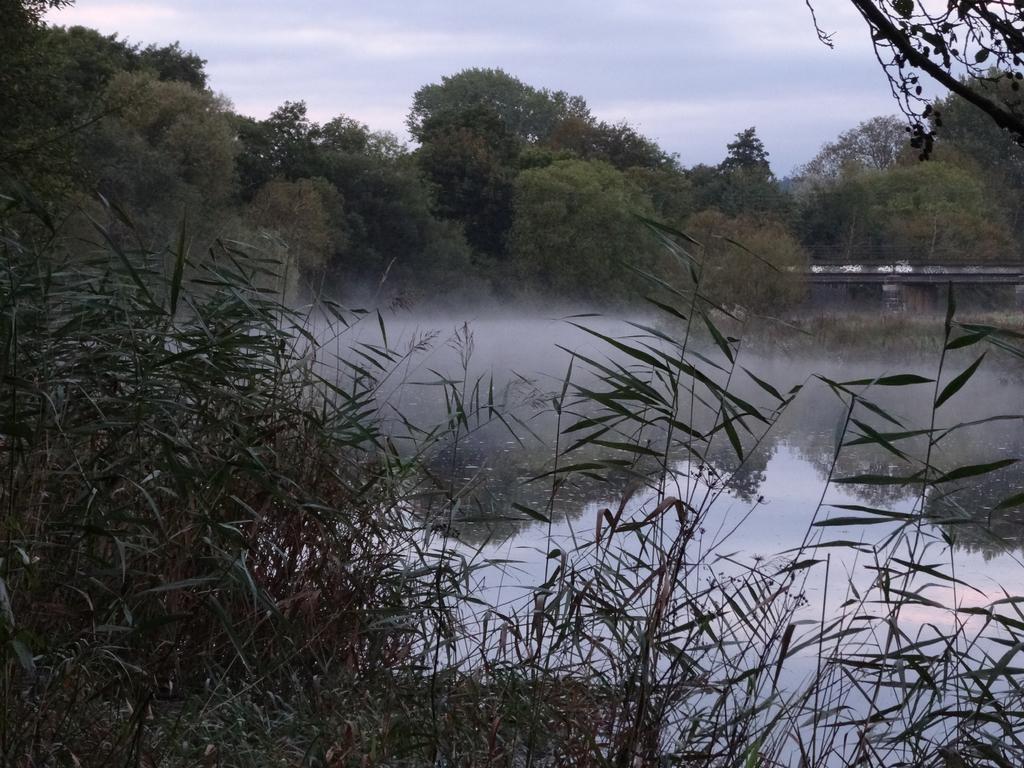Can you describe this image briefly? In this picture we can see there are trees, water and a bridge. At the top of the image, there is the sky. At the bottom of the image, there are plants. 